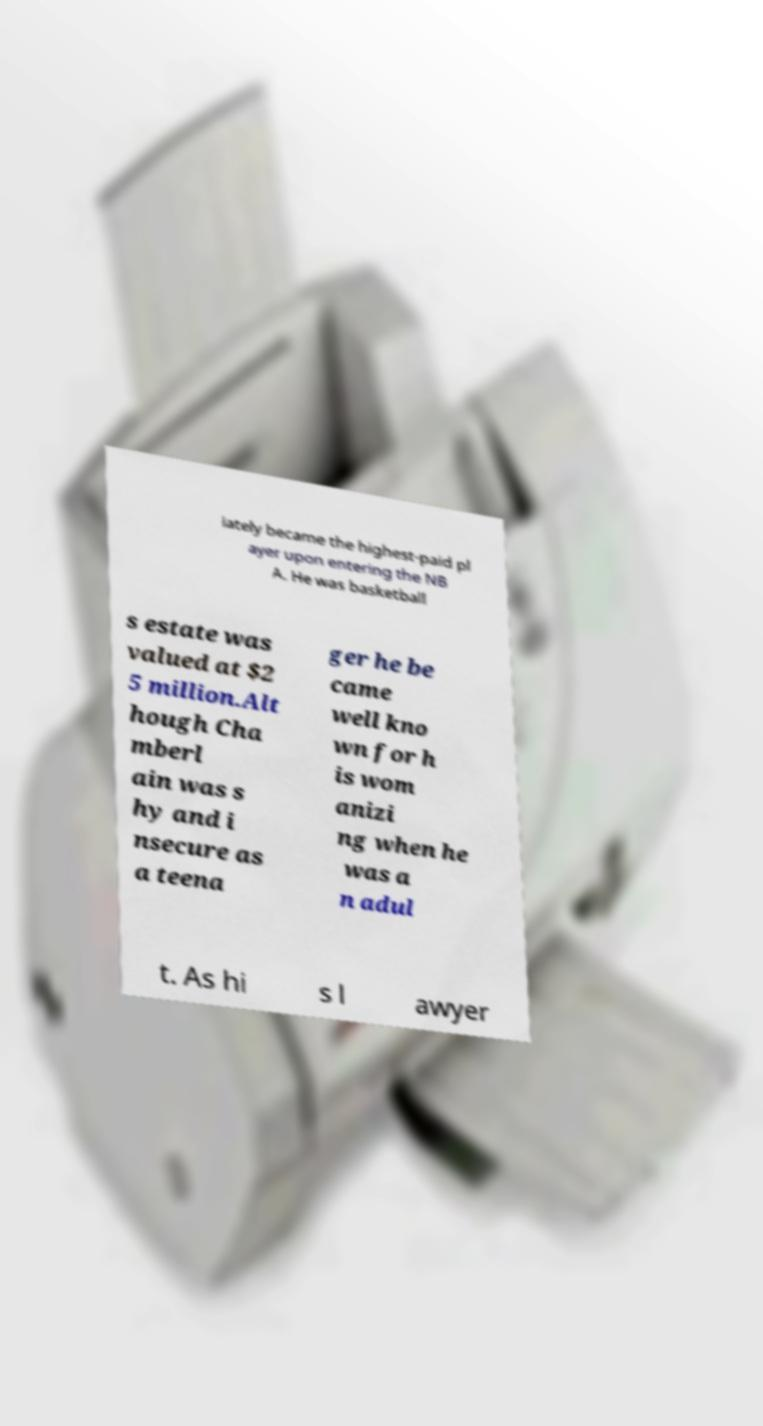There's text embedded in this image that I need extracted. Can you transcribe it verbatim? iately became the highest-paid pl ayer upon entering the NB A. He was basketball s estate was valued at $2 5 million.Alt hough Cha mberl ain was s hy and i nsecure as a teena ger he be came well kno wn for h is wom anizi ng when he was a n adul t. As hi s l awyer 